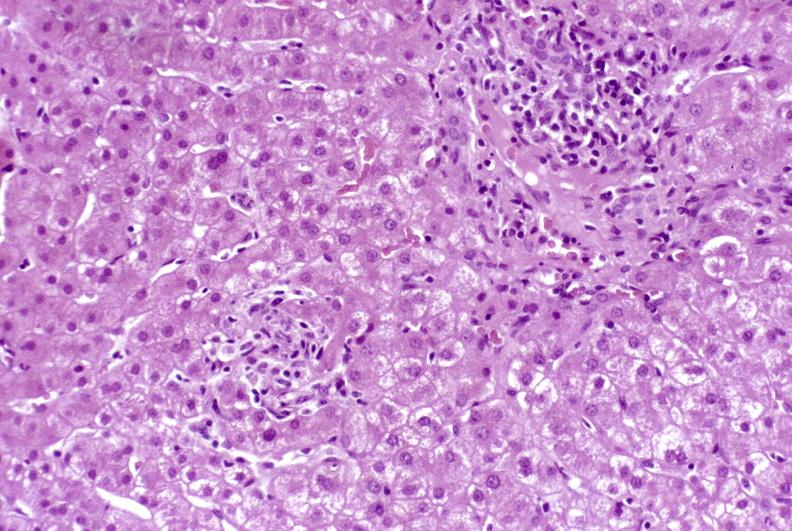does hypertrophic gastritis show granulomas?
Answer the question using a single word or phrase. No 